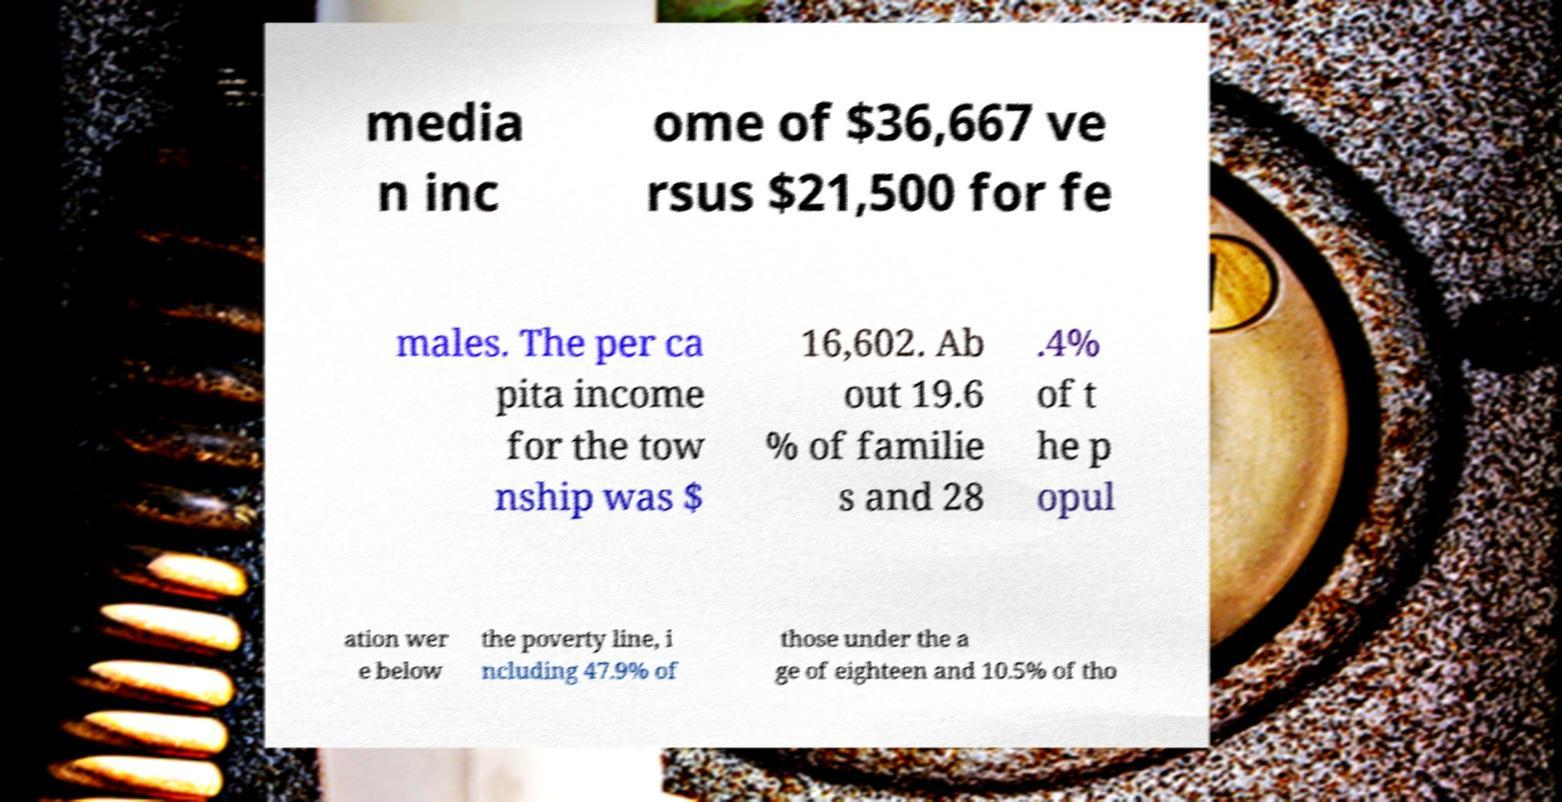Can you read and provide the text displayed in the image?This photo seems to have some interesting text. Can you extract and type it out for me? media n inc ome of $36,667 ve rsus $21,500 for fe males. The per ca pita income for the tow nship was $ 16,602. Ab out 19.6 % of familie s and 28 .4% of t he p opul ation wer e below the poverty line, i ncluding 47.9% of those under the a ge of eighteen and 10.5% of tho 